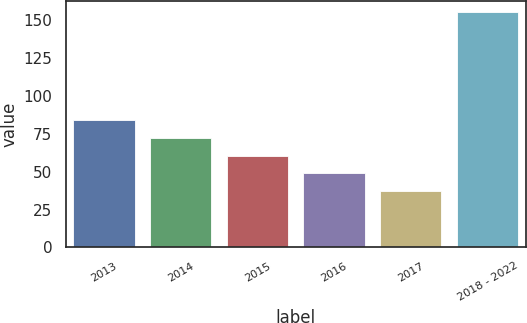Convert chart to OTSL. <chart><loc_0><loc_0><loc_500><loc_500><bar_chart><fcel>2013<fcel>2014<fcel>2015<fcel>2016<fcel>2017<fcel>2018 - 2022<nl><fcel>84.2<fcel>72.4<fcel>60.6<fcel>48.8<fcel>37<fcel>155<nl></chart> 